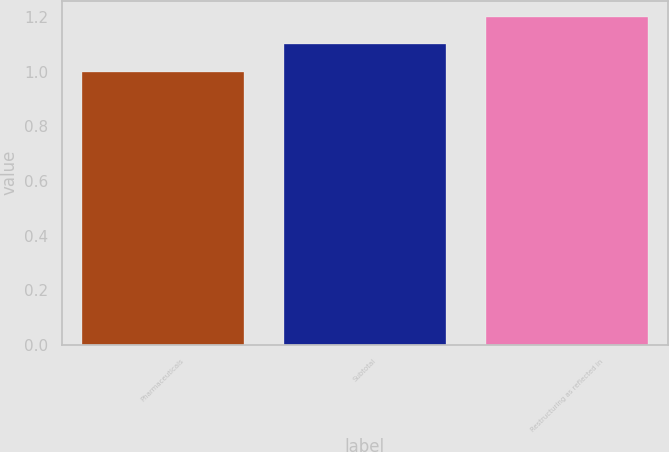Convert chart to OTSL. <chart><loc_0><loc_0><loc_500><loc_500><bar_chart><fcel>Pharmaceuticals<fcel>Subtotal<fcel>Restructuring as reflected in<nl><fcel>1<fcel>1.1<fcel>1.2<nl></chart> 